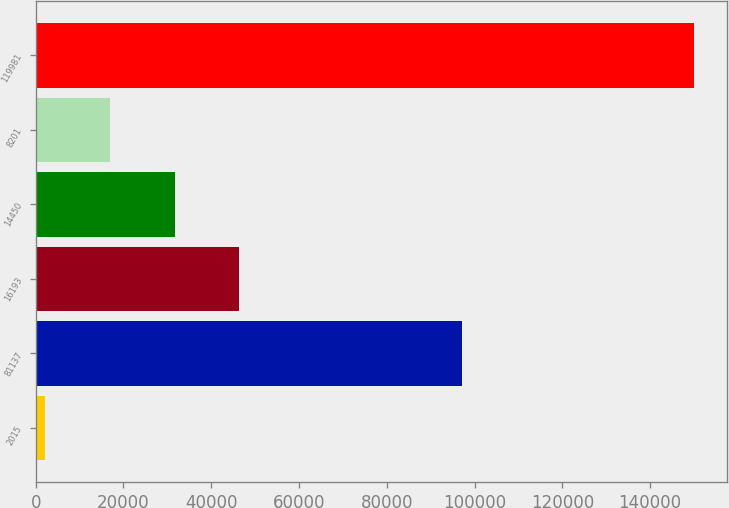Convert chart to OTSL. <chart><loc_0><loc_0><loc_500><loc_500><bar_chart><fcel>2015<fcel>81137<fcel>16193<fcel>14450<fcel>8201<fcel>119981<nl><fcel>2013<fcel>97146<fcel>46430.1<fcel>31624.4<fcel>16818.7<fcel>150070<nl></chart> 